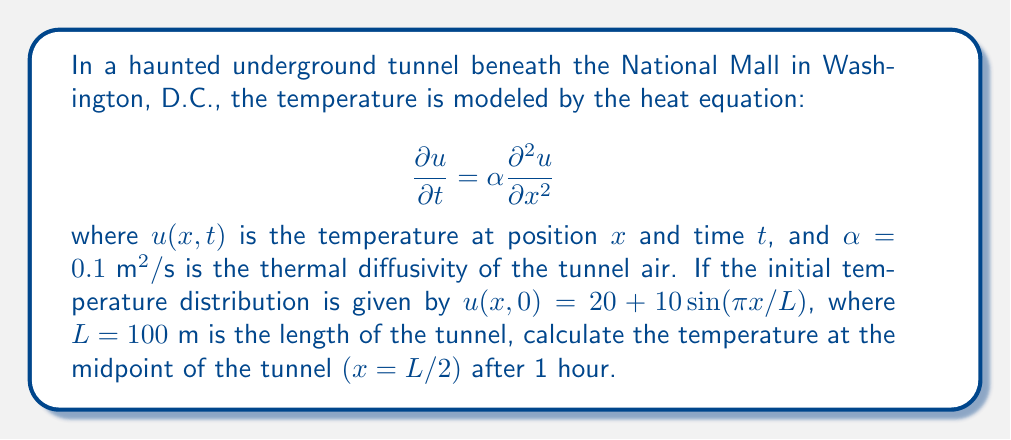Teach me how to tackle this problem. To solve this problem, we'll use the separation of variables method for the heat equation:

1) The general solution for the heat equation with the given initial condition is:

   $$u(x,t) = 20 + 10e^{-\alpha(\pi/L)^2t}\sin(\pi x/L)$$

2) We need to calculate $u(L/2, 3600)$, as 1 hour = 3600 seconds:

   $$u(L/2, 3600) = 20 + 10e^{-\alpha(\pi/L)^2(3600)}\sin(\pi (L/2)/L)$$

3) Simplify $\sin(\pi (L/2)/L)$:
   
   $$\sin(\pi (L/2)/L) = \sin(\pi/2) = 1$$

4) Substitute the known values:
   
   $$u(L/2, 3600) = 20 + 10e^{-0.1(\pi/100)^2(3600)}(1)$$

5) Calculate the exponent:
   
   $$-0.1(\pi/100)^2(3600) \approx -0.3553$$

6) Simplify:
   
   $$u(L/2, 3600) = 20 + 10e^{-0.3553} \approx 20 + 10(0.7009)$$

7) Final calculation:
   
   $$u(L/2, 3600) \approx 20 + 7.009 \approx 27.009$$
Answer: $27.009°C$ 